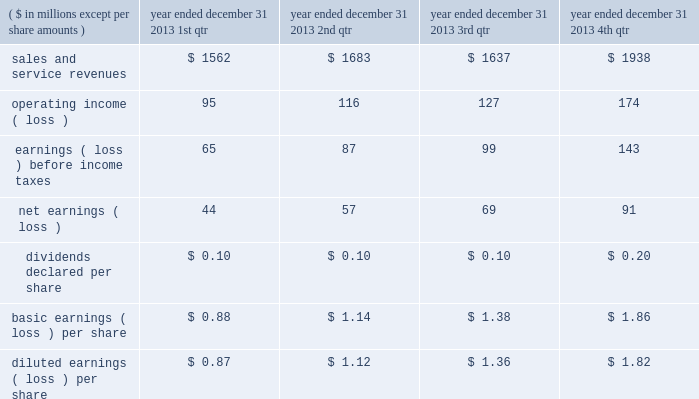"three factor formula" ) .
The consolidated financial statements include northrop grumman management and support services allocations totaling $ 32 million for the year ended december 31 , 2011 .
Shared services and infrastructure costs - this category includes costs for functions such as information technology support , systems maintenance , telecommunications , procurement and other shared services while hii was a subsidiary of northrop grumman .
These costs were generally allocated to the company using the three factor formula or based on usage .
The consolidated financial statements reflect shared services and infrastructure costs allocations totaling $ 80 million for the year ended december 31 , 2011 .
Northrop grumman-provided benefits - this category includes costs for group medical , dental and vision insurance , 401 ( k ) savings plan , pension and postretirement benefits , incentive compensation and other benefits .
These costs were generally allocated to the company based on specific identification of the benefits provided to company employees participating in these benefit plans .
The consolidated financial statements include northrop grumman- provided benefits allocations totaling $ 169 million for the year ended december 31 , 2011 .
Management believes that the methods of allocating these costs are reasonable , consistent with past practices , and in conformity with cost allocation requirements of cas or the far .
Related party sales and cost of sales prior to the spin-off , hii purchased and sold certain products and services from and to other northrop grumman entities .
Purchases of products and services from these affiliated entities , which were recorded at cost , were $ 44 million for the year ended december 31 , 2011 .
Sales of products and services to these entities were $ 1 million for the year ended december 31 , 2011 .
Former parent's equity in unit transactions between hii and northrop grumman prior to the spin-off have been included in the consolidated financial statements and were effectively settled for cash at the time the transaction was recorded .
The net effect of the settlement of these transactions is reflected as former parent's equity in unit in the consolidated statement of changes in equity .
21 .
Unaudited selected quarterly data unaudited quarterly financial results for the years ended december 31 , 2013 and 2012 , are set forth in the tables: .

What were the total net earnings year ended december 31 2013 in millions? 
Rationale: the total net earnings for the year is the sum of the quarterly earnings
Computations: ((44 + 57) + 69)
Answer: 170.0. 